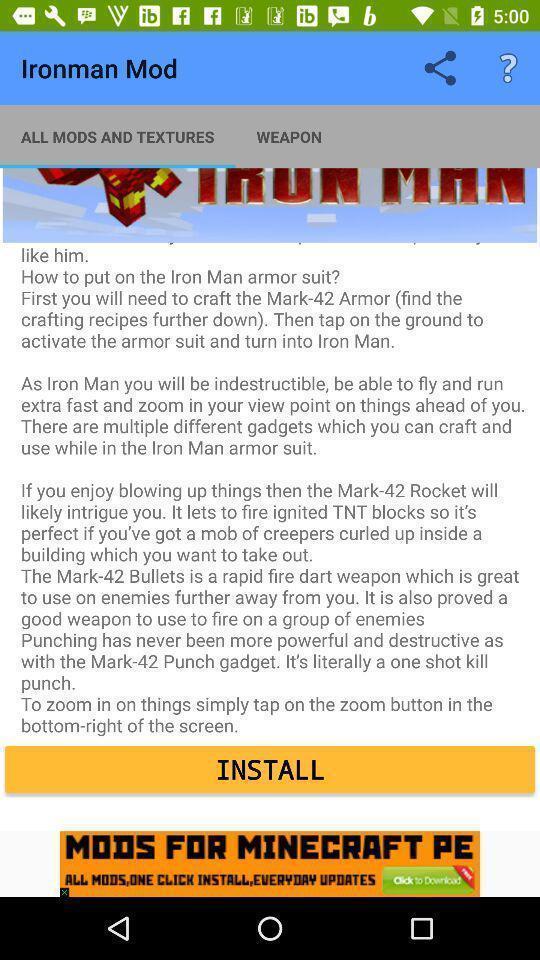Describe this image in words. Screen showing page. 